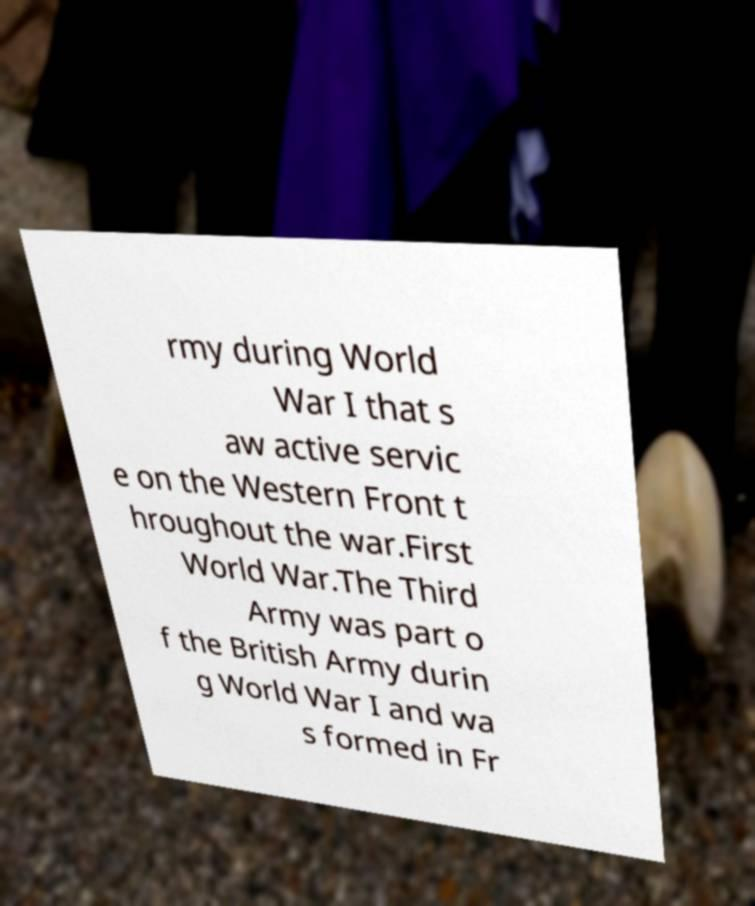Can you accurately transcribe the text from the provided image for me? rmy during World War I that s aw active servic e on the Western Front t hroughout the war.First World War.The Third Army was part o f the British Army durin g World War I and wa s formed in Fr 